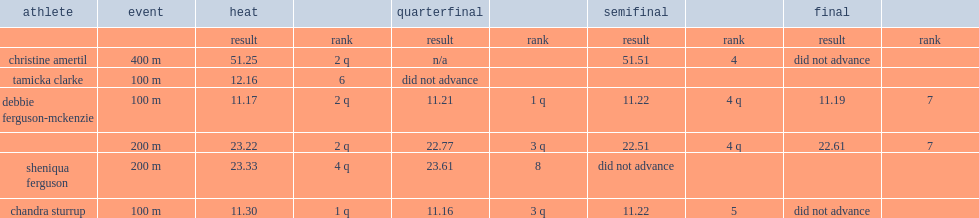What was the result in quarterfinal at the 2008 summer olympics made by debbie ferguson-mckenzie? 22.77. 